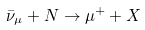<formula> <loc_0><loc_0><loc_500><loc_500>\bar { \nu } _ { \mu } + N \to \mu ^ { + } + X</formula> 